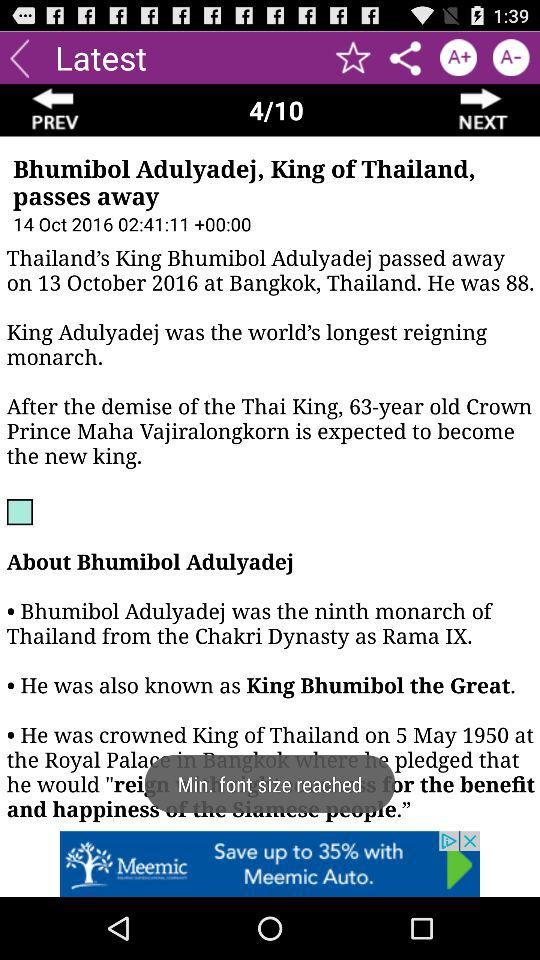How old was the King of Thailand? The King of Thailand was 88 years old. 